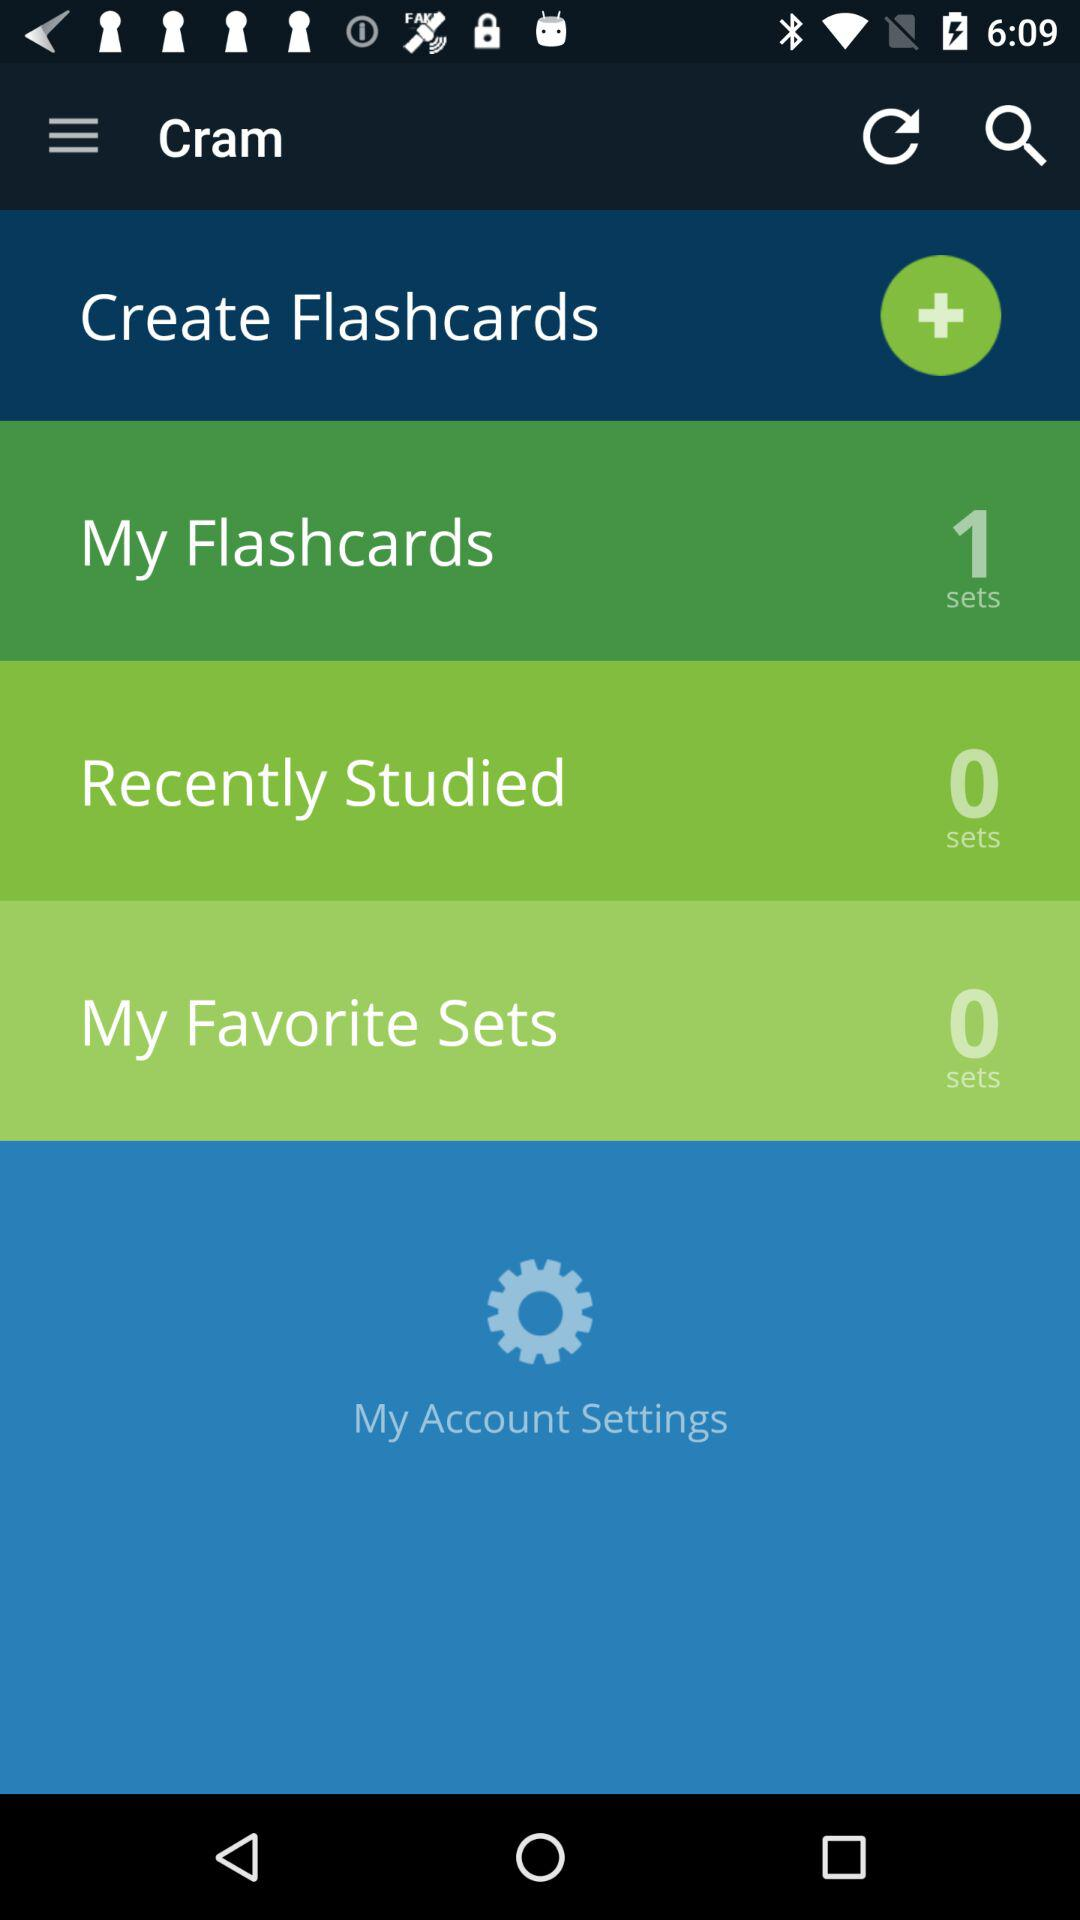How many flashcards have been studied recently? The number of flashcards that have been studied recently is 0. 